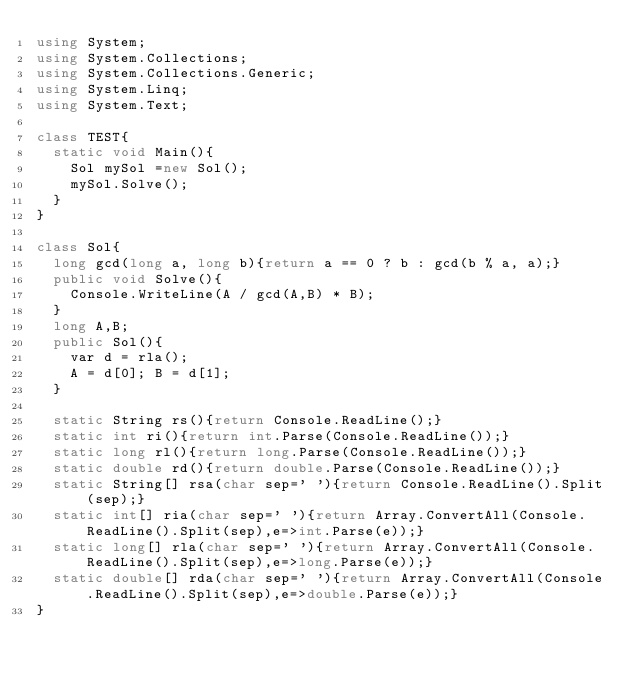Convert code to text. <code><loc_0><loc_0><loc_500><loc_500><_C#_>using System;
using System.Collections;
using System.Collections.Generic;
using System.Linq;
using System.Text;

class TEST{
	static void Main(){
		Sol mySol =new Sol();
		mySol.Solve();
	}
}

class Sol{
	long gcd(long a, long b){return a == 0 ? b : gcd(b % a, a);}
	public void Solve(){
		Console.WriteLine(A / gcd(A,B) * B);
	}
	long A,B;
	public Sol(){
		var d = rla();
		A = d[0]; B = d[1];
	}

	static String rs(){return Console.ReadLine();}
	static int ri(){return int.Parse(Console.ReadLine());}
	static long rl(){return long.Parse(Console.ReadLine());}
	static double rd(){return double.Parse(Console.ReadLine());}
	static String[] rsa(char sep=' '){return Console.ReadLine().Split(sep);}
	static int[] ria(char sep=' '){return Array.ConvertAll(Console.ReadLine().Split(sep),e=>int.Parse(e));}
	static long[] rla(char sep=' '){return Array.ConvertAll(Console.ReadLine().Split(sep),e=>long.Parse(e));}
	static double[] rda(char sep=' '){return Array.ConvertAll(Console.ReadLine().Split(sep),e=>double.Parse(e));}
}
</code> 